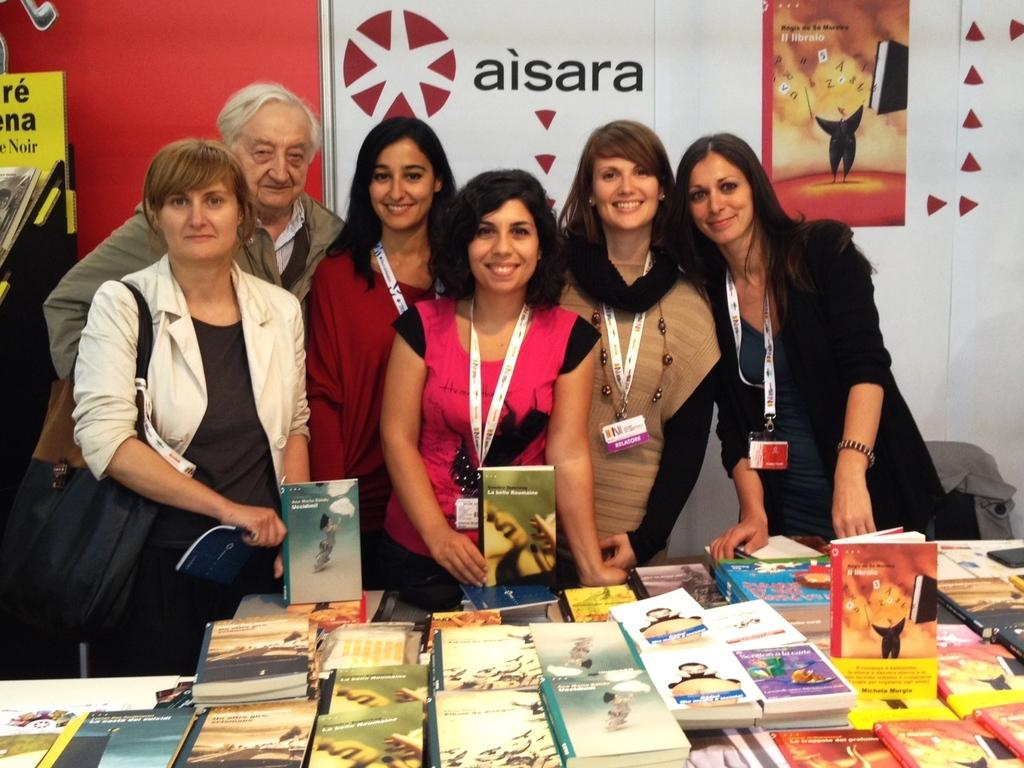<image>
Render a clear and concise summary of the photo. A small group of people pose in front of an Aisara poster. 